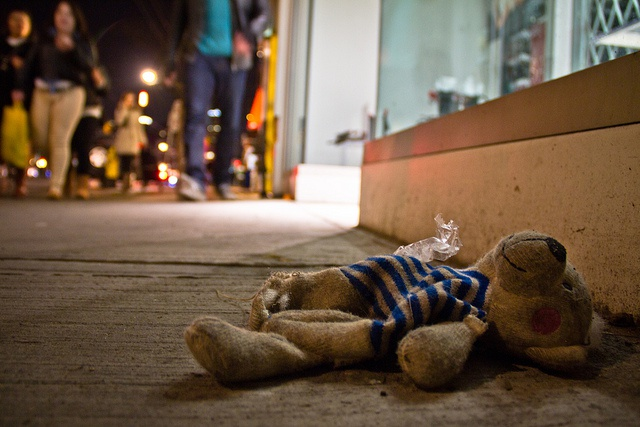Describe the objects in this image and their specific colors. I can see teddy bear in black, maroon, and gray tones, people in black, gray, and maroon tones, people in black, gray, brown, and maroon tones, people in black, olive, and maroon tones, and people in black, tan, brown, gray, and maroon tones in this image. 